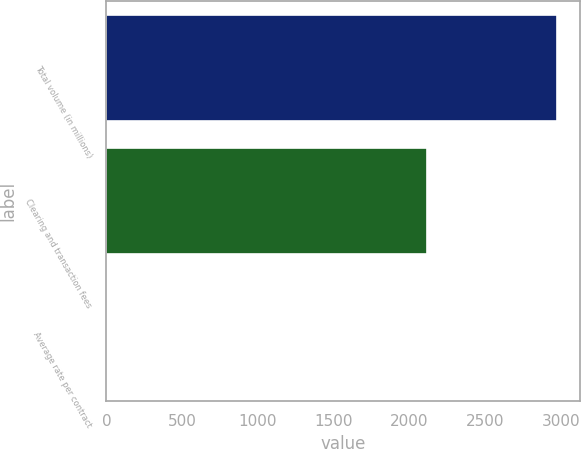<chart> <loc_0><loc_0><loc_500><loc_500><bar_chart><fcel>Total volume (in millions)<fcel>Clearing and transaction fees<fcel>Average rate per contract<nl><fcel>2978.5<fcel>2114.7<fcel>0.71<nl></chart> 